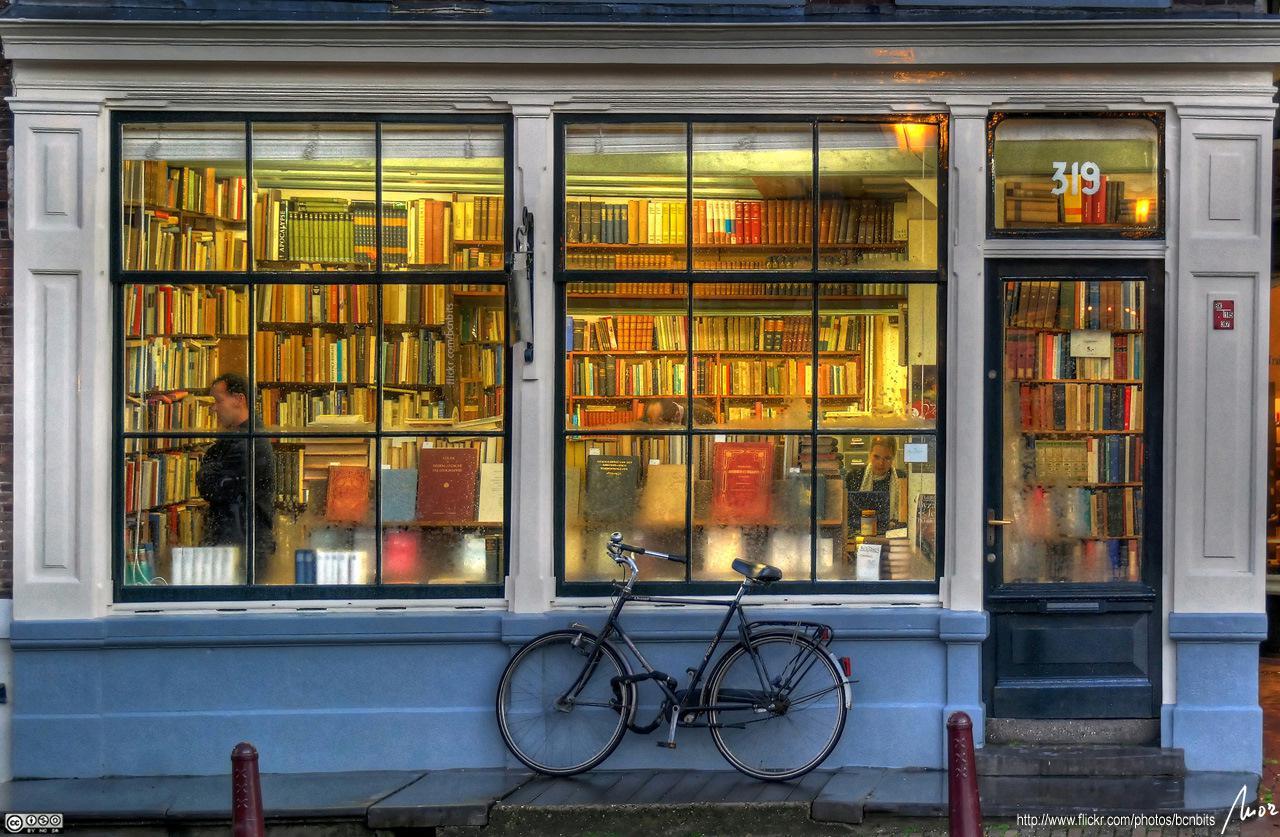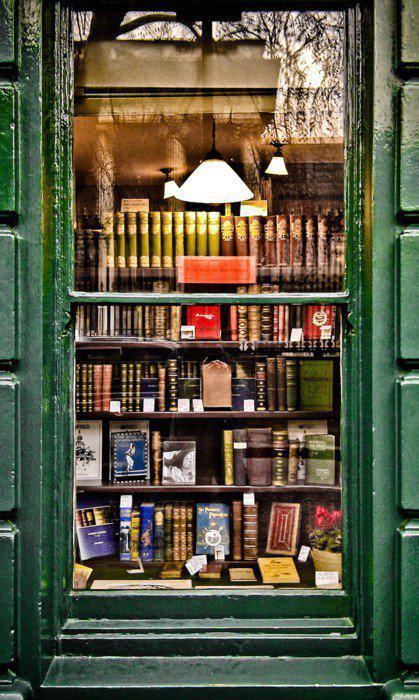The first image is the image on the left, the second image is the image on the right. Given the left and right images, does the statement "A bookstore in a brick building is shown in one image with people on the sidewalk outside, with a second image showing outdoor book racks." hold true? Answer yes or no. No. The first image is the image on the left, the second image is the image on the right. Analyze the images presented: Is the assertion "A sign hangs outside the door of a brick bookstore in each of the images." valid? Answer yes or no. No. 